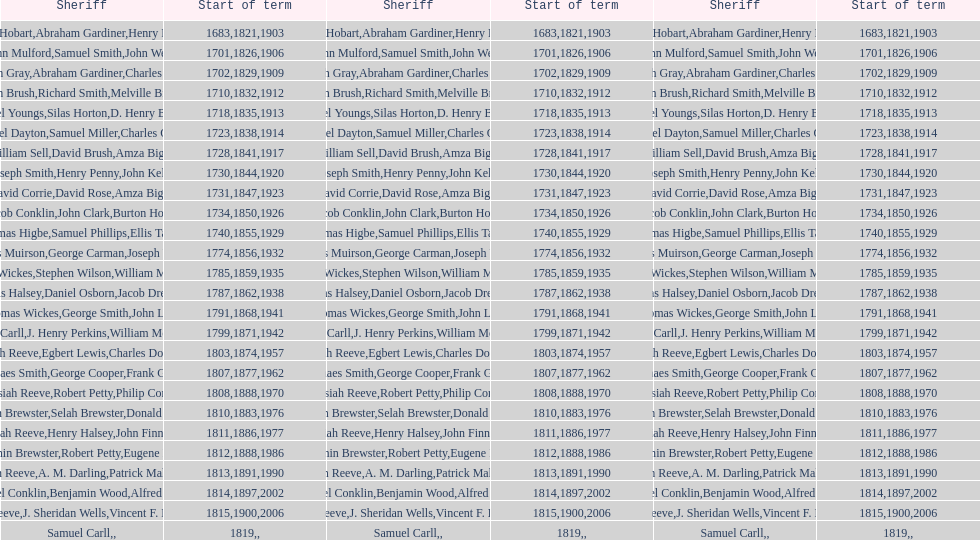When did the first sheriff's term start? 1683. 